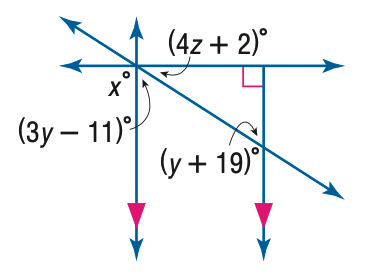Question: Find y in the figure.
Choices:
A. 13
B. 13.5
C. 14
D. 15
Answer with the letter. Answer: D Question: Find z in the figure.
Choices:
A. 13.5
B. 14
C. 14.5
D. 15
Answer with the letter. Answer: A Question: Find x in the figure.
Choices:
A. 13.5
B. 15
C. 90
D. 180
Answer with the letter. Answer: C 